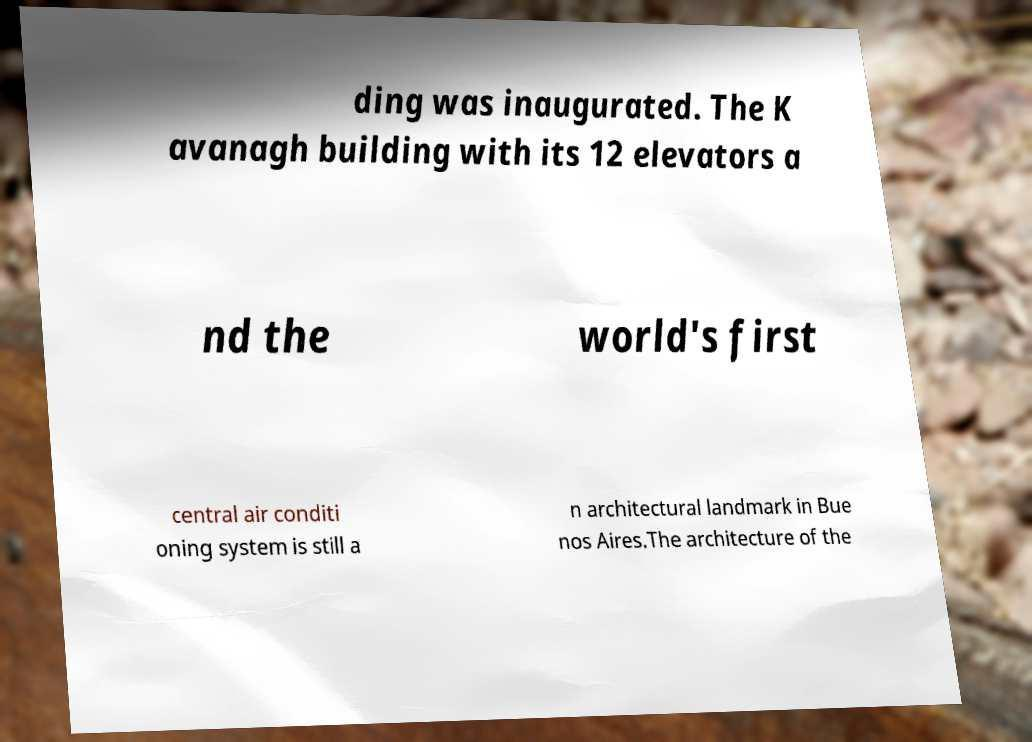Could you extract and type out the text from this image? ding was inaugurated. The K avanagh building with its 12 elevators a nd the world's first central air conditi oning system is still a n architectural landmark in Bue nos Aires.The architecture of the 